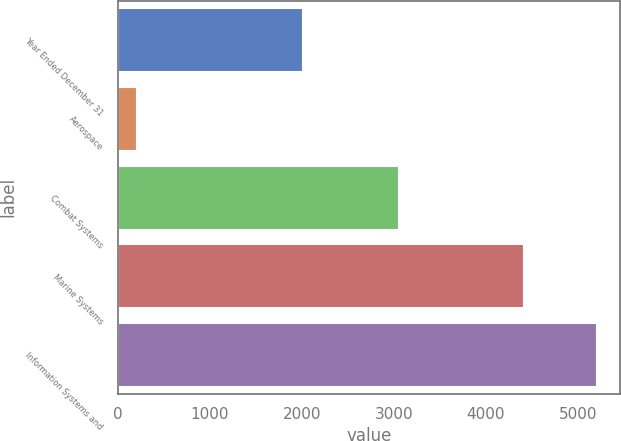<chart> <loc_0><loc_0><loc_500><loc_500><bar_chart><fcel>Year Ended December 31<fcel>Aerospace<fcel>Combat Systems<fcel>Marine Systems<fcel>Information Systems and<nl><fcel>2004<fcel>199<fcel>3048<fcel>4407<fcel>5201<nl></chart> 